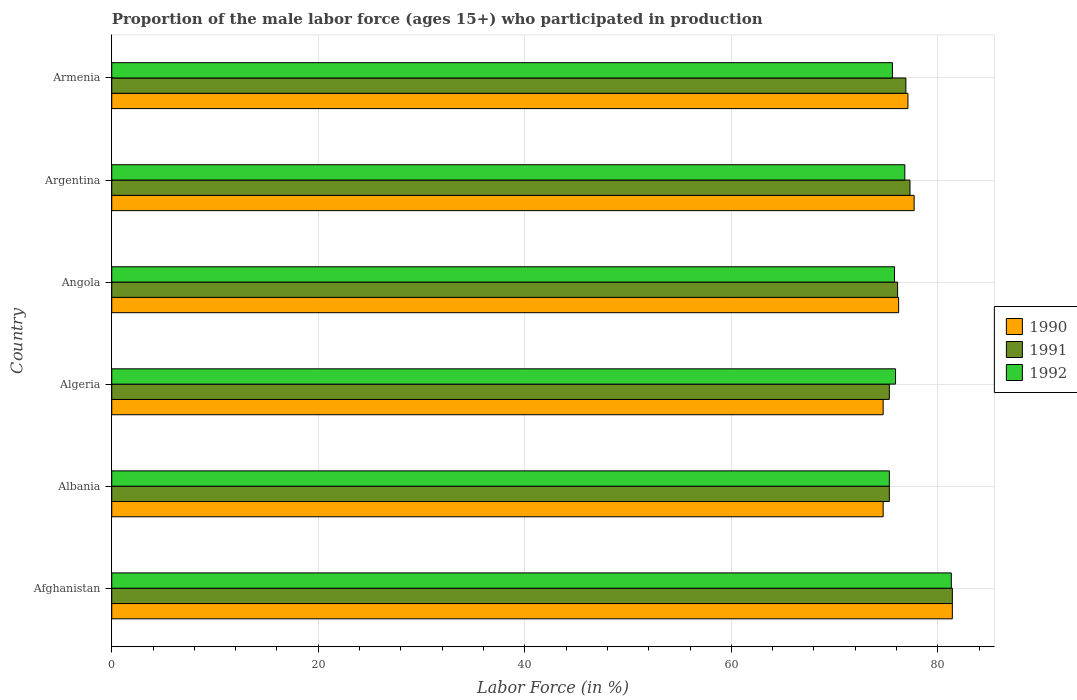How many different coloured bars are there?
Provide a succinct answer. 3. Are the number of bars on each tick of the Y-axis equal?
Make the answer very short. Yes. What is the label of the 5th group of bars from the top?
Provide a succinct answer. Albania. In how many cases, is the number of bars for a given country not equal to the number of legend labels?
Make the answer very short. 0. What is the proportion of the male labor force who participated in production in 1992 in Albania?
Your answer should be compact. 75.3. Across all countries, what is the maximum proportion of the male labor force who participated in production in 1991?
Give a very brief answer. 81.4. Across all countries, what is the minimum proportion of the male labor force who participated in production in 1991?
Ensure brevity in your answer.  75.3. In which country was the proportion of the male labor force who participated in production in 1992 maximum?
Ensure brevity in your answer.  Afghanistan. In which country was the proportion of the male labor force who participated in production in 1990 minimum?
Offer a very short reply. Albania. What is the total proportion of the male labor force who participated in production in 1991 in the graph?
Offer a terse response. 462.3. What is the difference between the proportion of the male labor force who participated in production in 1992 in Afghanistan and that in Algeria?
Ensure brevity in your answer.  5.4. What is the difference between the proportion of the male labor force who participated in production in 1991 in Armenia and the proportion of the male labor force who participated in production in 1990 in Angola?
Your answer should be very brief. 0.7. What is the average proportion of the male labor force who participated in production in 1991 per country?
Offer a very short reply. 77.05. What is the difference between the proportion of the male labor force who participated in production in 1991 and proportion of the male labor force who participated in production in 1992 in Angola?
Keep it short and to the point. 0.3. What is the ratio of the proportion of the male labor force who participated in production in 1991 in Albania to that in Armenia?
Provide a short and direct response. 0.98. What is the difference between the highest and the lowest proportion of the male labor force who participated in production in 1990?
Give a very brief answer. 6.7. What does the 3rd bar from the top in Albania represents?
Your answer should be compact. 1990. What does the 2nd bar from the bottom in Albania represents?
Provide a succinct answer. 1991. Are all the bars in the graph horizontal?
Offer a terse response. Yes. Are the values on the major ticks of X-axis written in scientific E-notation?
Offer a terse response. No. Does the graph contain any zero values?
Provide a succinct answer. No. Does the graph contain grids?
Your answer should be very brief. Yes. How many legend labels are there?
Offer a very short reply. 3. What is the title of the graph?
Give a very brief answer. Proportion of the male labor force (ages 15+) who participated in production. Does "2003" appear as one of the legend labels in the graph?
Offer a terse response. No. What is the label or title of the X-axis?
Provide a succinct answer. Labor Force (in %). What is the Labor Force (in %) in 1990 in Afghanistan?
Offer a very short reply. 81.4. What is the Labor Force (in %) in 1991 in Afghanistan?
Provide a succinct answer. 81.4. What is the Labor Force (in %) of 1992 in Afghanistan?
Keep it short and to the point. 81.3. What is the Labor Force (in %) in 1990 in Albania?
Give a very brief answer. 74.7. What is the Labor Force (in %) of 1991 in Albania?
Your answer should be very brief. 75.3. What is the Labor Force (in %) of 1992 in Albania?
Give a very brief answer. 75.3. What is the Labor Force (in %) of 1990 in Algeria?
Your response must be concise. 74.7. What is the Labor Force (in %) in 1991 in Algeria?
Offer a terse response. 75.3. What is the Labor Force (in %) in 1992 in Algeria?
Provide a succinct answer. 75.9. What is the Labor Force (in %) of 1990 in Angola?
Provide a short and direct response. 76.2. What is the Labor Force (in %) in 1991 in Angola?
Ensure brevity in your answer.  76.1. What is the Labor Force (in %) of 1992 in Angola?
Keep it short and to the point. 75.8. What is the Labor Force (in %) in 1990 in Argentina?
Ensure brevity in your answer.  77.7. What is the Labor Force (in %) of 1991 in Argentina?
Your answer should be compact. 77.3. What is the Labor Force (in %) of 1992 in Argentina?
Give a very brief answer. 76.8. What is the Labor Force (in %) in 1990 in Armenia?
Offer a terse response. 77.1. What is the Labor Force (in %) in 1991 in Armenia?
Offer a very short reply. 76.9. What is the Labor Force (in %) of 1992 in Armenia?
Your answer should be compact. 75.6. Across all countries, what is the maximum Labor Force (in %) of 1990?
Ensure brevity in your answer.  81.4. Across all countries, what is the maximum Labor Force (in %) in 1991?
Your answer should be compact. 81.4. Across all countries, what is the maximum Labor Force (in %) in 1992?
Your answer should be very brief. 81.3. Across all countries, what is the minimum Labor Force (in %) in 1990?
Offer a very short reply. 74.7. Across all countries, what is the minimum Labor Force (in %) of 1991?
Keep it short and to the point. 75.3. Across all countries, what is the minimum Labor Force (in %) of 1992?
Offer a terse response. 75.3. What is the total Labor Force (in %) in 1990 in the graph?
Your response must be concise. 461.8. What is the total Labor Force (in %) of 1991 in the graph?
Offer a very short reply. 462.3. What is the total Labor Force (in %) of 1992 in the graph?
Provide a short and direct response. 460.7. What is the difference between the Labor Force (in %) in 1991 in Afghanistan and that in Albania?
Make the answer very short. 6.1. What is the difference between the Labor Force (in %) in 1992 in Afghanistan and that in Albania?
Your response must be concise. 6. What is the difference between the Labor Force (in %) of 1990 in Afghanistan and that in Algeria?
Your answer should be compact. 6.7. What is the difference between the Labor Force (in %) of 1992 in Afghanistan and that in Angola?
Your answer should be compact. 5.5. What is the difference between the Labor Force (in %) of 1991 in Afghanistan and that in Armenia?
Give a very brief answer. 4.5. What is the difference between the Labor Force (in %) in 1992 in Albania and that in Algeria?
Provide a short and direct response. -0.6. What is the difference between the Labor Force (in %) in 1991 in Albania and that in Angola?
Offer a very short reply. -0.8. What is the difference between the Labor Force (in %) in 1992 in Albania and that in Angola?
Make the answer very short. -0.5. What is the difference between the Labor Force (in %) of 1990 in Albania and that in Argentina?
Provide a succinct answer. -3. What is the difference between the Labor Force (in %) of 1991 in Albania and that in Argentina?
Your answer should be compact. -2. What is the difference between the Labor Force (in %) in 1992 in Albania and that in Argentina?
Offer a very short reply. -1.5. What is the difference between the Labor Force (in %) in 1991 in Albania and that in Armenia?
Your response must be concise. -1.6. What is the difference between the Labor Force (in %) in 1990 in Algeria and that in Angola?
Keep it short and to the point. -1.5. What is the difference between the Labor Force (in %) in 1990 in Algeria and that in Argentina?
Offer a very short reply. -3. What is the difference between the Labor Force (in %) in 1992 in Angola and that in Argentina?
Keep it short and to the point. -1. What is the difference between the Labor Force (in %) in 1991 in Angola and that in Armenia?
Offer a very short reply. -0.8. What is the difference between the Labor Force (in %) of 1992 in Angola and that in Armenia?
Give a very brief answer. 0.2. What is the difference between the Labor Force (in %) in 1990 in Argentina and that in Armenia?
Your response must be concise. 0.6. What is the difference between the Labor Force (in %) of 1991 in Argentina and that in Armenia?
Give a very brief answer. 0.4. What is the difference between the Labor Force (in %) of 1992 in Argentina and that in Armenia?
Your answer should be very brief. 1.2. What is the difference between the Labor Force (in %) in 1991 in Afghanistan and the Labor Force (in %) in 1992 in Albania?
Your answer should be very brief. 6.1. What is the difference between the Labor Force (in %) in 1990 in Afghanistan and the Labor Force (in %) in 1991 in Algeria?
Provide a short and direct response. 6.1. What is the difference between the Labor Force (in %) in 1990 in Afghanistan and the Labor Force (in %) in 1992 in Algeria?
Give a very brief answer. 5.5. What is the difference between the Labor Force (in %) of 1991 in Afghanistan and the Labor Force (in %) of 1992 in Algeria?
Your answer should be compact. 5.5. What is the difference between the Labor Force (in %) of 1990 in Afghanistan and the Labor Force (in %) of 1991 in Angola?
Offer a very short reply. 5.3. What is the difference between the Labor Force (in %) of 1991 in Afghanistan and the Labor Force (in %) of 1992 in Angola?
Provide a short and direct response. 5.6. What is the difference between the Labor Force (in %) of 1990 in Afghanistan and the Labor Force (in %) of 1992 in Argentina?
Offer a terse response. 4.6. What is the difference between the Labor Force (in %) of 1991 in Afghanistan and the Labor Force (in %) of 1992 in Argentina?
Ensure brevity in your answer.  4.6. What is the difference between the Labor Force (in %) of 1991 in Afghanistan and the Labor Force (in %) of 1992 in Armenia?
Keep it short and to the point. 5.8. What is the difference between the Labor Force (in %) of 1990 in Albania and the Labor Force (in %) of 1991 in Algeria?
Make the answer very short. -0.6. What is the difference between the Labor Force (in %) of 1990 in Albania and the Labor Force (in %) of 1992 in Angola?
Your answer should be very brief. -1.1. What is the difference between the Labor Force (in %) of 1991 in Albania and the Labor Force (in %) of 1992 in Angola?
Your answer should be very brief. -0.5. What is the difference between the Labor Force (in %) in 1990 in Albania and the Labor Force (in %) in 1991 in Argentina?
Your answer should be compact. -2.6. What is the difference between the Labor Force (in %) of 1991 in Albania and the Labor Force (in %) of 1992 in Argentina?
Your answer should be compact. -1.5. What is the difference between the Labor Force (in %) of 1990 in Albania and the Labor Force (in %) of 1991 in Armenia?
Give a very brief answer. -2.2. What is the difference between the Labor Force (in %) in 1990 in Albania and the Labor Force (in %) in 1992 in Armenia?
Offer a very short reply. -0.9. What is the difference between the Labor Force (in %) in 1990 in Algeria and the Labor Force (in %) in 1991 in Angola?
Provide a succinct answer. -1.4. What is the difference between the Labor Force (in %) of 1991 in Algeria and the Labor Force (in %) of 1992 in Angola?
Ensure brevity in your answer.  -0.5. What is the difference between the Labor Force (in %) in 1990 in Algeria and the Labor Force (in %) in 1992 in Armenia?
Provide a short and direct response. -0.9. What is the difference between the Labor Force (in %) of 1991 in Algeria and the Labor Force (in %) of 1992 in Armenia?
Offer a very short reply. -0.3. What is the difference between the Labor Force (in %) of 1990 in Angola and the Labor Force (in %) of 1991 in Argentina?
Ensure brevity in your answer.  -1.1. What is the difference between the Labor Force (in %) of 1991 in Angola and the Labor Force (in %) of 1992 in Argentina?
Offer a terse response. -0.7. What is the difference between the Labor Force (in %) in 1990 in Angola and the Labor Force (in %) in 1991 in Armenia?
Offer a very short reply. -0.7. What is the difference between the Labor Force (in %) of 1990 in Angola and the Labor Force (in %) of 1992 in Armenia?
Offer a very short reply. 0.6. What is the difference between the Labor Force (in %) of 1990 in Argentina and the Labor Force (in %) of 1992 in Armenia?
Your response must be concise. 2.1. What is the average Labor Force (in %) in 1990 per country?
Ensure brevity in your answer.  76.97. What is the average Labor Force (in %) in 1991 per country?
Your answer should be compact. 77.05. What is the average Labor Force (in %) in 1992 per country?
Keep it short and to the point. 76.78. What is the difference between the Labor Force (in %) of 1990 and Labor Force (in %) of 1992 in Afghanistan?
Your response must be concise. 0.1. What is the difference between the Labor Force (in %) in 1990 and Labor Force (in %) in 1992 in Albania?
Keep it short and to the point. -0.6. What is the difference between the Labor Force (in %) in 1991 and Labor Force (in %) in 1992 in Albania?
Your answer should be very brief. 0. What is the difference between the Labor Force (in %) in 1990 and Labor Force (in %) in 1991 in Algeria?
Your answer should be very brief. -0.6. What is the difference between the Labor Force (in %) of 1991 and Labor Force (in %) of 1992 in Algeria?
Offer a terse response. -0.6. What is the difference between the Labor Force (in %) of 1990 and Labor Force (in %) of 1991 in Angola?
Make the answer very short. 0.1. What is the difference between the Labor Force (in %) in 1990 and Labor Force (in %) in 1992 in Angola?
Offer a very short reply. 0.4. What is the difference between the Labor Force (in %) in 1991 and Labor Force (in %) in 1992 in Angola?
Ensure brevity in your answer.  0.3. What is the difference between the Labor Force (in %) in 1990 and Labor Force (in %) in 1992 in Armenia?
Keep it short and to the point. 1.5. What is the ratio of the Labor Force (in %) in 1990 in Afghanistan to that in Albania?
Your answer should be very brief. 1.09. What is the ratio of the Labor Force (in %) of 1991 in Afghanistan to that in Albania?
Provide a succinct answer. 1.08. What is the ratio of the Labor Force (in %) of 1992 in Afghanistan to that in Albania?
Offer a terse response. 1.08. What is the ratio of the Labor Force (in %) of 1990 in Afghanistan to that in Algeria?
Make the answer very short. 1.09. What is the ratio of the Labor Force (in %) in 1991 in Afghanistan to that in Algeria?
Keep it short and to the point. 1.08. What is the ratio of the Labor Force (in %) in 1992 in Afghanistan to that in Algeria?
Your response must be concise. 1.07. What is the ratio of the Labor Force (in %) in 1990 in Afghanistan to that in Angola?
Your answer should be compact. 1.07. What is the ratio of the Labor Force (in %) of 1991 in Afghanistan to that in Angola?
Provide a short and direct response. 1.07. What is the ratio of the Labor Force (in %) of 1992 in Afghanistan to that in Angola?
Your answer should be compact. 1.07. What is the ratio of the Labor Force (in %) in 1990 in Afghanistan to that in Argentina?
Provide a short and direct response. 1.05. What is the ratio of the Labor Force (in %) of 1991 in Afghanistan to that in Argentina?
Provide a short and direct response. 1.05. What is the ratio of the Labor Force (in %) in 1992 in Afghanistan to that in Argentina?
Give a very brief answer. 1.06. What is the ratio of the Labor Force (in %) in 1990 in Afghanistan to that in Armenia?
Your response must be concise. 1.06. What is the ratio of the Labor Force (in %) in 1991 in Afghanistan to that in Armenia?
Your answer should be compact. 1.06. What is the ratio of the Labor Force (in %) of 1992 in Afghanistan to that in Armenia?
Provide a succinct answer. 1.08. What is the ratio of the Labor Force (in %) in 1991 in Albania to that in Algeria?
Keep it short and to the point. 1. What is the ratio of the Labor Force (in %) of 1992 in Albania to that in Algeria?
Offer a terse response. 0.99. What is the ratio of the Labor Force (in %) of 1990 in Albania to that in Angola?
Your answer should be very brief. 0.98. What is the ratio of the Labor Force (in %) of 1990 in Albania to that in Argentina?
Provide a short and direct response. 0.96. What is the ratio of the Labor Force (in %) in 1991 in Albania to that in Argentina?
Provide a short and direct response. 0.97. What is the ratio of the Labor Force (in %) in 1992 in Albania to that in Argentina?
Offer a very short reply. 0.98. What is the ratio of the Labor Force (in %) in 1990 in Albania to that in Armenia?
Offer a terse response. 0.97. What is the ratio of the Labor Force (in %) in 1991 in Albania to that in Armenia?
Offer a terse response. 0.98. What is the ratio of the Labor Force (in %) of 1990 in Algeria to that in Angola?
Your response must be concise. 0.98. What is the ratio of the Labor Force (in %) in 1991 in Algeria to that in Angola?
Offer a terse response. 0.99. What is the ratio of the Labor Force (in %) of 1992 in Algeria to that in Angola?
Your answer should be compact. 1. What is the ratio of the Labor Force (in %) of 1990 in Algeria to that in Argentina?
Offer a very short reply. 0.96. What is the ratio of the Labor Force (in %) in 1991 in Algeria to that in Argentina?
Your response must be concise. 0.97. What is the ratio of the Labor Force (in %) of 1992 in Algeria to that in Argentina?
Give a very brief answer. 0.99. What is the ratio of the Labor Force (in %) in 1990 in Algeria to that in Armenia?
Offer a very short reply. 0.97. What is the ratio of the Labor Force (in %) in 1991 in Algeria to that in Armenia?
Provide a short and direct response. 0.98. What is the ratio of the Labor Force (in %) of 1990 in Angola to that in Argentina?
Ensure brevity in your answer.  0.98. What is the ratio of the Labor Force (in %) in 1991 in Angola to that in Argentina?
Provide a short and direct response. 0.98. What is the ratio of the Labor Force (in %) in 1992 in Angola to that in Argentina?
Offer a terse response. 0.99. What is the ratio of the Labor Force (in %) of 1990 in Angola to that in Armenia?
Provide a succinct answer. 0.99. What is the ratio of the Labor Force (in %) of 1991 in Angola to that in Armenia?
Offer a terse response. 0.99. What is the ratio of the Labor Force (in %) in 1990 in Argentina to that in Armenia?
Offer a terse response. 1.01. What is the ratio of the Labor Force (in %) of 1991 in Argentina to that in Armenia?
Provide a short and direct response. 1.01. What is the ratio of the Labor Force (in %) in 1992 in Argentina to that in Armenia?
Your answer should be compact. 1.02. What is the difference between the highest and the second highest Labor Force (in %) in 1990?
Provide a short and direct response. 3.7. What is the difference between the highest and the second highest Labor Force (in %) in 1991?
Keep it short and to the point. 4.1. What is the difference between the highest and the second highest Labor Force (in %) in 1992?
Give a very brief answer. 4.5. 